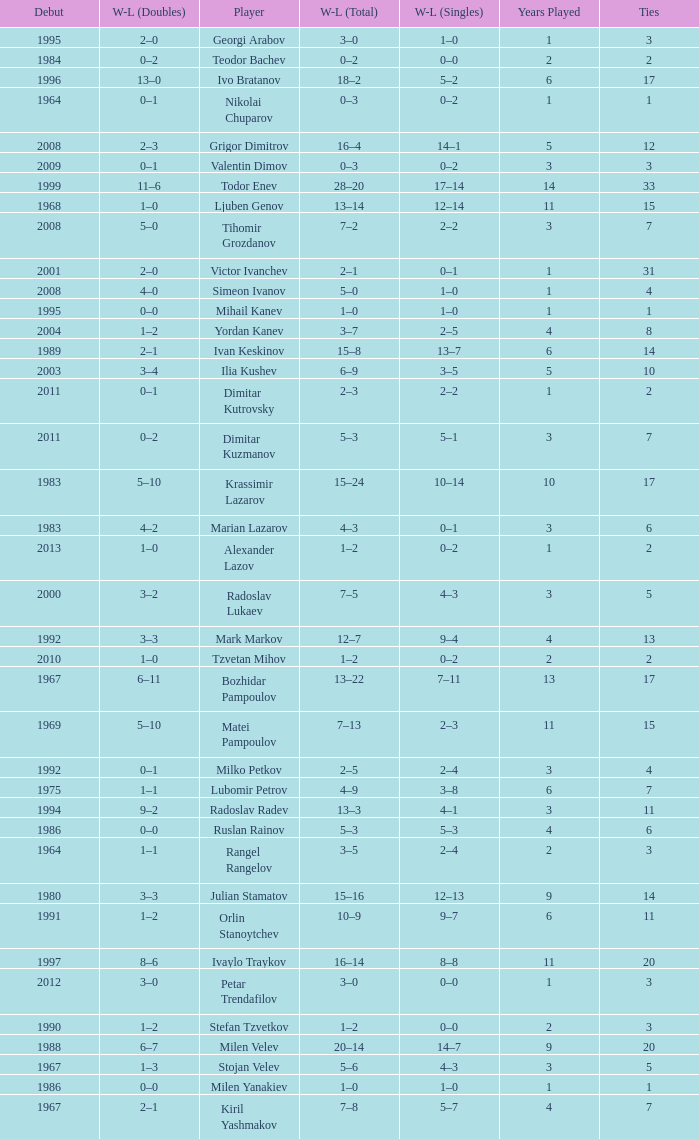Tell me the WL doubles with a debut of 1999 11–6. 